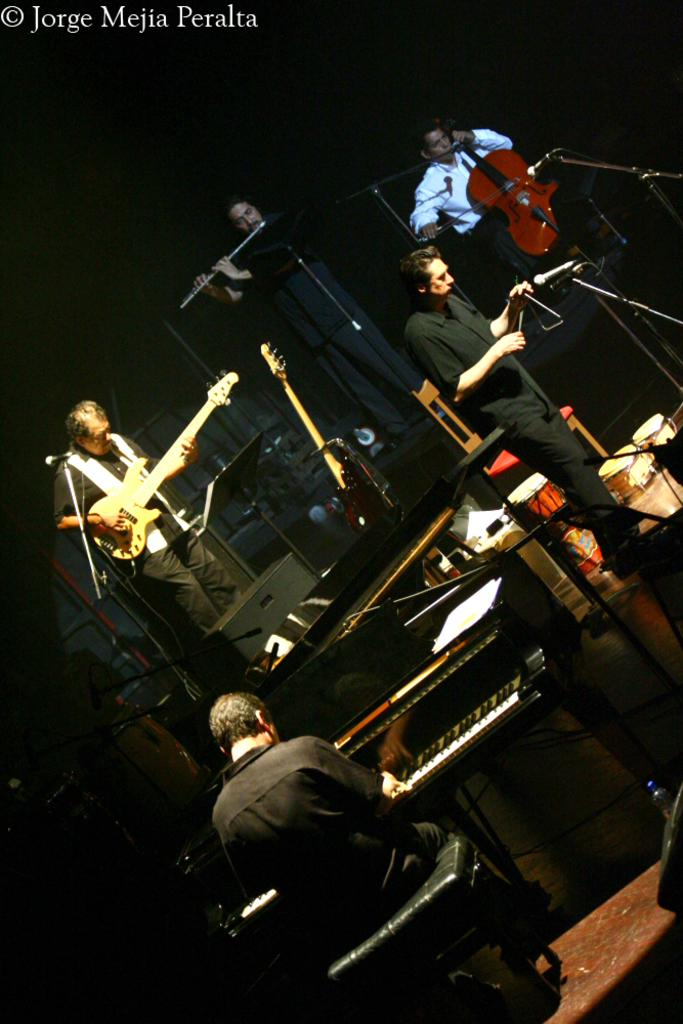What are the persons in the image doing? The persons in the image are standing and playing musical instruments. Can you describe the person sitting in the image? There is a person sitting on a chair and playing a piano. What objects are present in the image that are related to music? There are musical instruments present, including a piano, and a mic with a mic holder. Where is the sink located in the image? There is no sink present in the image. Can you see any cattle in the image? There are no cattle present in the image. 